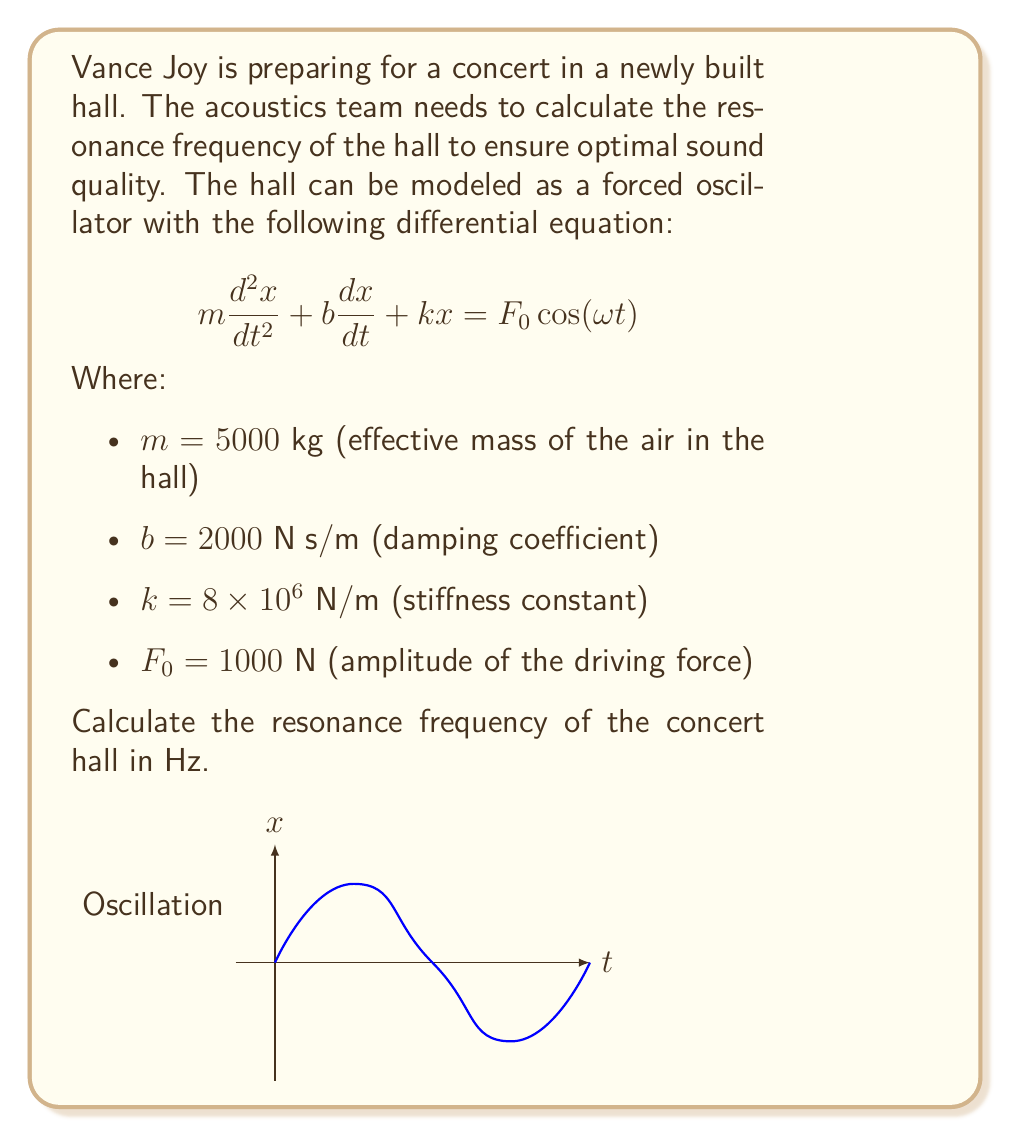What is the answer to this math problem? To find the resonance frequency of the concert hall, we need to follow these steps:

1) The resonance frequency of a forced oscillator is equal to the natural frequency of the system when there is no damping. We can ignore the damping term and the forcing term in our calculation.

2) The natural frequency $\omega_n$ of an undamped system is given by:

   $$\omega_n = \sqrt{\frac{k}{m}}$$

3) Let's substitute our values:
   
   $$\omega_n = \sqrt{\frac{8 \times 10^6}{5000}}$$

4) Calculate:
   
   $$\omega_n = \sqrt{1600} = 40 \text{ rad/s}$$

5) To convert from angular frequency (rad/s) to frequency (Hz), we use the formula:

   $$f = \frac{\omega}{2\pi}$$

6) Substituting our value:

   $$f = \frac{40}{2\pi} \approx 6.37 \text{ Hz}$$

Therefore, the resonance frequency of the concert hall is approximately 6.37 Hz.
Answer: 6.37 Hz 